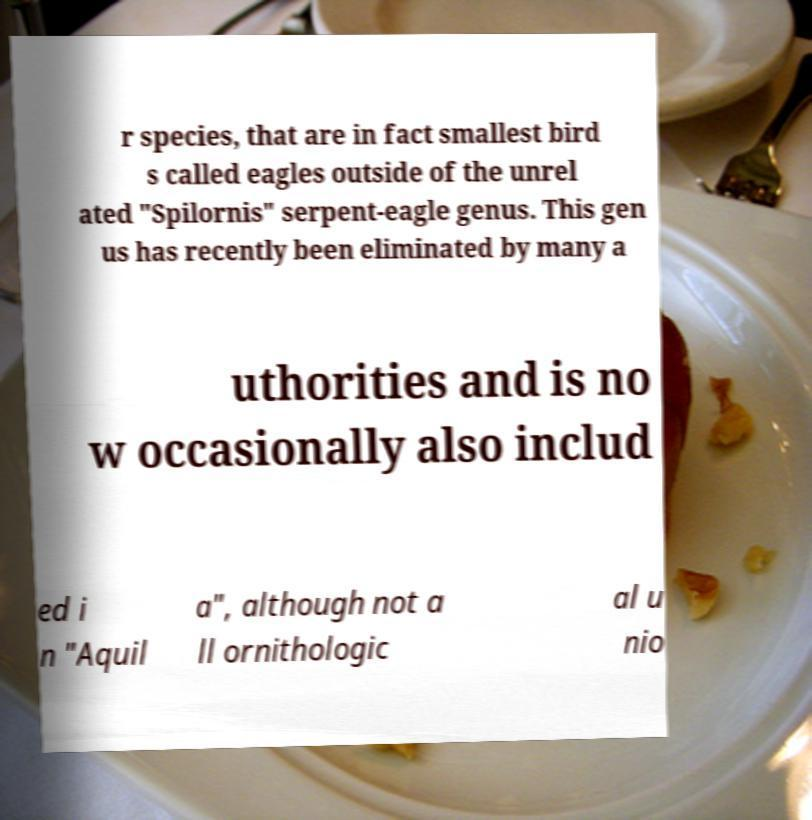Could you assist in decoding the text presented in this image and type it out clearly? r species, that are in fact smallest bird s called eagles outside of the unrel ated "Spilornis" serpent-eagle genus. This gen us has recently been eliminated by many a uthorities and is no w occasionally also includ ed i n "Aquil a", although not a ll ornithologic al u nio 